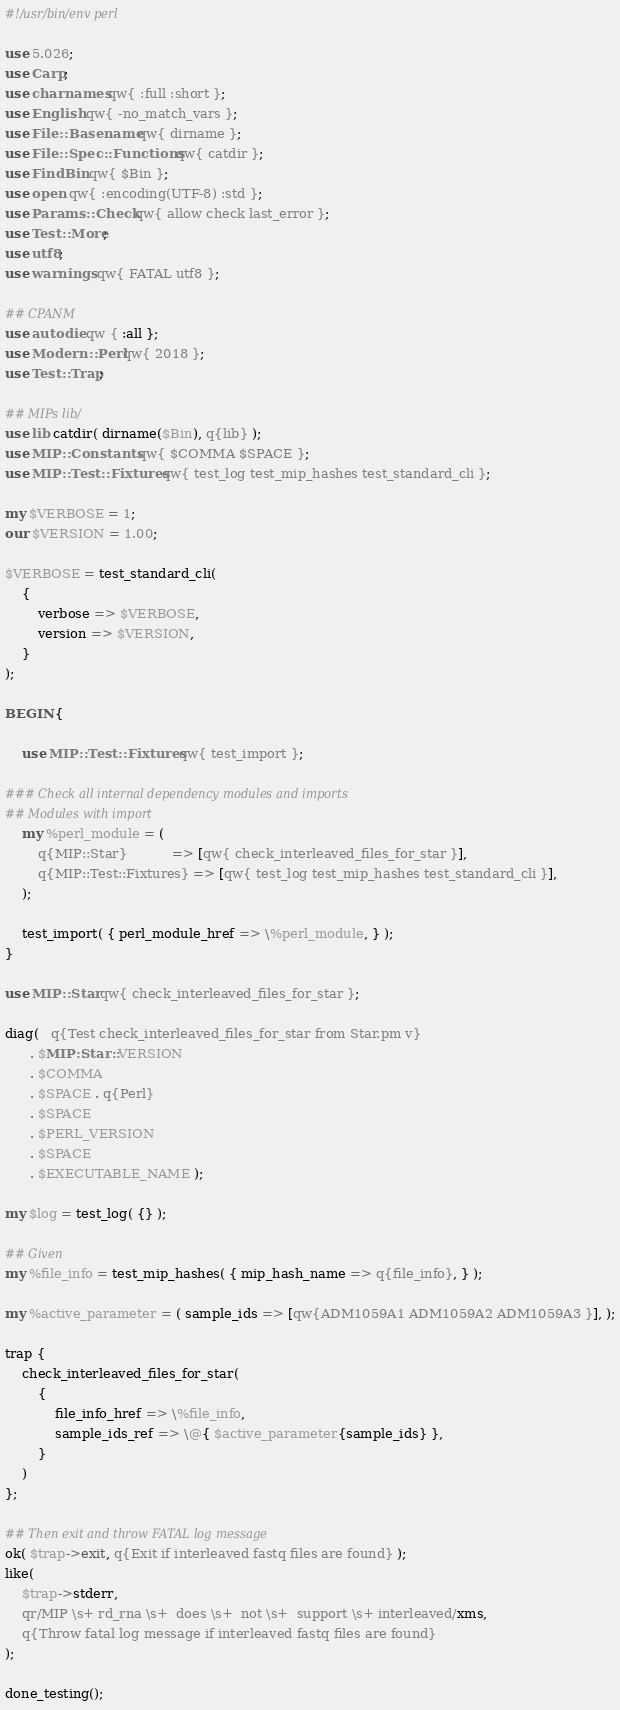<code> <loc_0><loc_0><loc_500><loc_500><_Perl_>#!/usr/bin/env perl

use 5.026;
use Carp;
use charnames qw{ :full :short };
use English qw{ -no_match_vars };
use File::Basename qw{ dirname };
use File::Spec::Functions qw{ catdir };
use FindBin qw{ $Bin };
use open qw{ :encoding(UTF-8) :std };
use Params::Check qw{ allow check last_error };
use Test::More;
use utf8;
use warnings qw{ FATAL utf8 };

## CPANM
use autodie qw { :all };
use Modern::Perl qw{ 2018 };
use Test::Trap;

## MIPs lib/
use lib catdir( dirname($Bin), q{lib} );
use MIP::Constants qw{ $COMMA $SPACE };
use MIP::Test::Fixtures qw{ test_log test_mip_hashes test_standard_cli };

my $VERBOSE = 1;
our $VERSION = 1.00;

$VERBOSE = test_standard_cli(
    {
        verbose => $VERBOSE,
        version => $VERSION,
    }
);

BEGIN {

    use MIP::Test::Fixtures qw{ test_import };

### Check all internal dependency modules and imports
## Modules with import
    my %perl_module = (
        q{MIP::Star}           => [qw{ check_interleaved_files_for_star }],
        q{MIP::Test::Fixtures} => [qw{ test_log test_mip_hashes test_standard_cli }],
    );

    test_import( { perl_module_href => \%perl_module, } );
}

use MIP::Star qw{ check_interleaved_files_for_star };

diag(   q{Test check_interleaved_files_for_star from Star.pm v}
      . $MIP::Star::VERSION
      . $COMMA
      . $SPACE . q{Perl}
      . $SPACE
      . $PERL_VERSION
      . $SPACE
      . $EXECUTABLE_NAME );

my $log = test_log( {} );

## Given
my %file_info = test_mip_hashes( { mip_hash_name => q{file_info}, } );

my %active_parameter = ( sample_ids => [qw{ADM1059A1 ADM1059A2 ADM1059A3 }], );

trap {
    check_interleaved_files_for_star(
        {
            file_info_href => \%file_info,
            sample_ids_ref => \@{ $active_parameter{sample_ids} },
        }
    )
};

## Then exit and throw FATAL log message
ok( $trap->exit, q{Exit if interleaved fastq files are found} );
like(
    $trap->stderr,
    qr/MIP \s+ rd_rna \s+  does \s+  not \s+  support \s+ interleaved/xms,
    q{Throw fatal log message if interleaved fastq files are found}
);

done_testing();
</code> 